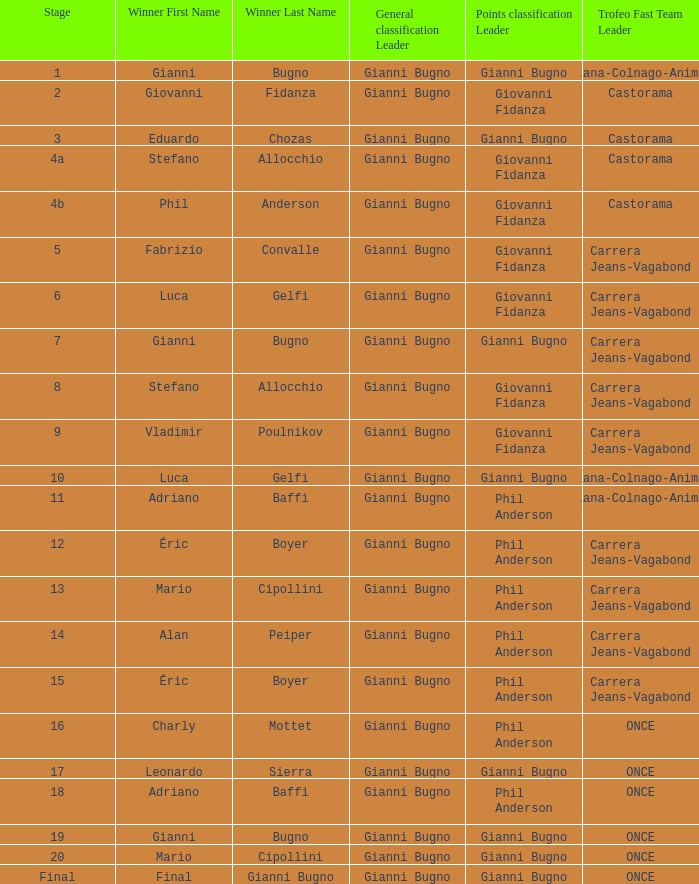Who was the trofeo fast team in stage 10? Diana-Colnago-Animex. 